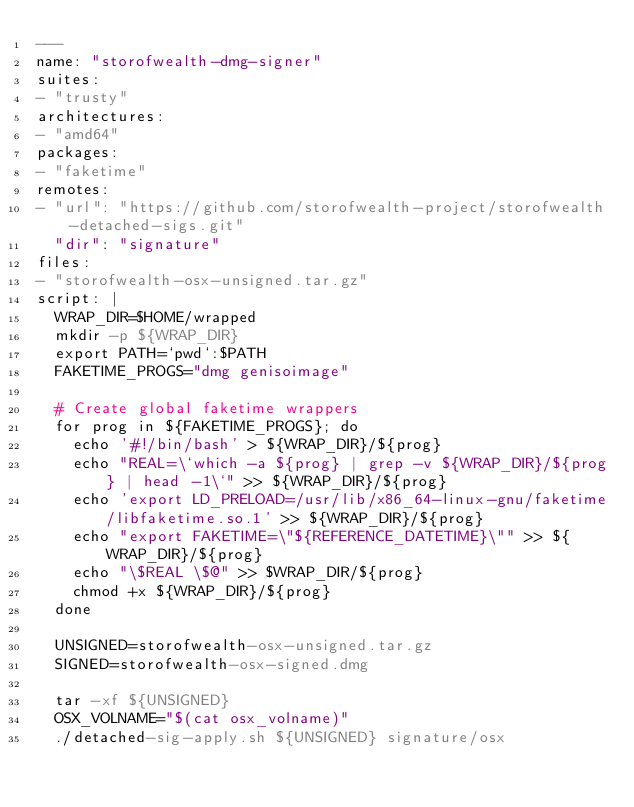<code> <loc_0><loc_0><loc_500><loc_500><_YAML_>---
name: "storofwealth-dmg-signer"
suites:
- "trusty"
architectures:
- "amd64"
packages:
- "faketime"
remotes:
- "url": "https://github.com/storofwealth-project/storofwealth-detached-sigs.git"
  "dir": "signature"
files:
- "storofwealth-osx-unsigned.tar.gz"
script: |
  WRAP_DIR=$HOME/wrapped
  mkdir -p ${WRAP_DIR}
  export PATH=`pwd`:$PATH
  FAKETIME_PROGS="dmg genisoimage"

  # Create global faketime wrappers
  for prog in ${FAKETIME_PROGS}; do
    echo '#!/bin/bash' > ${WRAP_DIR}/${prog}
    echo "REAL=\`which -a ${prog} | grep -v ${WRAP_DIR}/${prog} | head -1\`" >> ${WRAP_DIR}/${prog}
    echo 'export LD_PRELOAD=/usr/lib/x86_64-linux-gnu/faketime/libfaketime.so.1' >> ${WRAP_DIR}/${prog}
    echo "export FAKETIME=\"${REFERENCE_DATETIME}\"" >> ${WRAP_DIR}/${prog}
    echo "\$REAL \$@" >> $WRAP_DIR/${prog}
    chmod +x ${WRAP_DIR}/${prog}
  done

  UNSIGNED=storofwealth-osx-unsigned.tar.gz
  SIGNED=storofwealth-osx-signed.dmg

  tar -xf ${UNSIGNED}
  OSX_VOLNAME="$(cat osx_volname)"
  ./detached-sig-apply.sh ${UNSIGNED} signature/osx</code> 